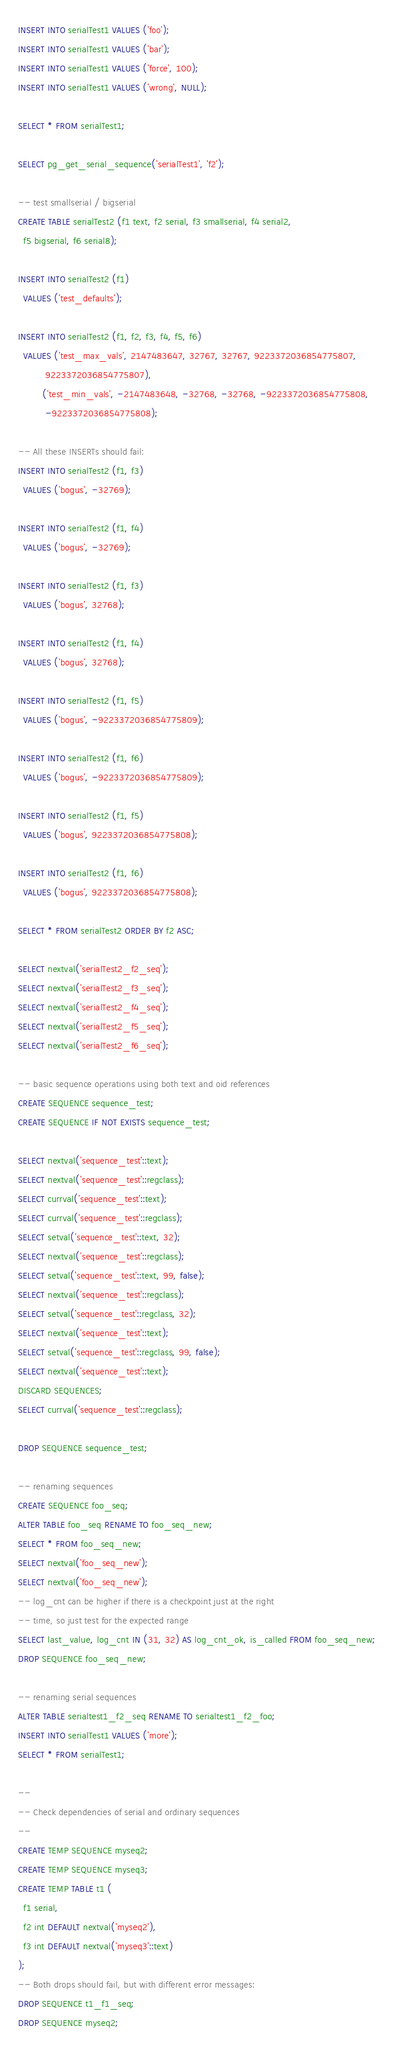<code> <loc_0><loc_0><loc_500><loc_500><_SQL_>INSERT INTO serialTest1 VALUES ('foo');
INSERT INTO serialTest1 VALUES ('bar');
INSERT INTO serialTest1 VALUES ('force', 100);
INSERT INTO serialTest1 VALUES ('wrong', NULL);

SELECT * FROM serialTest1;

SELECT pg_get_serial_sequence('serialTest1', 'f2');

-- test smallserial / bigserial
CREATE TABLE serialTest2 (f1 text, f2 serial, f3 smallserial, f4 serial2,
  f5 bigserial, f6 serial8);

INSERT INTO serialTest2 (f1)
  VALUES ('test_defaults');

INSERT INTO serialTest2 (f1, f2, f3, f4, f5, f6)
  VALUES ('test_max_vals', 2147483647, 32767, 32767, 9223372036854775807,
          9223372036854775807),
         ('test_min_vals', -2147483648, -32768, -32768, -9223372036854775808,
          -9223372036854775808);

-- All these INSERTs should fail:
INSERT INTO serialTest2 (f1, f3)
  VALUES ('bogus', -32769);

INSERT INTO serialTest2 (f1, f4)
  VALUES ('bogus', -32769);

INSERT INTO serialTest2 (f1, f3)
  VALUES ('bogus', 32768);

INSERT INTO serialTest2 (f1, f4)
  VALUES ('bogus', 32768);

INSERT INTO serialTest2 (f1, f5)
  VALUES ('bogus', -9223372036854775809);

INSERT INTO serialTest2 (f1, f6)
  VALUES ('bogus', -9223372036854775809);

INSERT INTO serialTest2 (f1, f5)
  VALUES ('bogus', 9223372036854775808);

INSERT INTO serialTest2 (f1, f6)
  VALUES ('bogus', 9223372036854775808);

SELECT * FROM serialTest2 ORDER BY f2 ASC;

SELECT nextval('serialTest2_f2_seq');
SELECT nextval('serialTest2_f3_seq');
SELECT nextval('serialTest2_f4_seq');
SELECT nextval('serialTest2_f5_seq');
SELECT nextval('serialTest2_f6_seq');

-- basic sequence operations using both text and oid references
CREATE SEQUENCE sequence_test;
CREATE SEQUENCE IF NOT EXISTS sequence_test;

SELECT nextval('sequence_test'::text);
SELECT nextval('sequence_test'::regclass);
SELECT currval('sequence_test'::text);
SELECT currval('sequence_test'::regclass);
SELECT setval('sequence_test'::text, 32);
SELECT nextval('sequence_test'::regclass);
SELECT setval('sequence_test'::text, 99, false);
SELECT nextval('sequence_test'::regclass);
SELECT setval('sequence_test'::regclass, 32);
SELECT nextval('sequence_test'::text);
SELECT setval('sequence_test'::regclass, 99, false);
SELECT nextval('sequence_test'::text);
DISCARD SEQUENCES;
SELECT currval('sequence_test'::regclass);

DROP SEQUENCE sequence_test;

-- renaming sequences
CREATE SEQUENCE foo_seq;
ALTER TABLE foo_seq RENAME TO foo_seq_new;
SELECT * FROM foo_seq_new;
SELECT nextval('foo_seq_new');
SELECT nextval('foo_seq_new');
-- log_cnt can be higher if there is a checkpoint just at the right
-- time, so just test for the expected range
SELECT last_value, log_cnt IN (31, 32) AS log_cnt_ok, is_called FROM foo_seq_new;
DROP SEQUENCE foo_seq_new;

-- renaming serial sequences
ALTER TABLE serialtest1_f2_seq RENAME TO serialtest1_f2_foo;
INSERT INTO serialTest1 VALUES ('more');
SELECT * FROM serialTest1;

--
-- Check dependencies of serial and ordinary sequences
--
CREATE TEMP SEQUENCE myseq2;
CREATE TEMP SEQUENCE myseq3;
CREATE TEMP TABLE t1 (
  f1 serial,
  f2 int DEFAULT nextval('myseq2'),
  f3 int DEFAULT nextval('myseq3'::text)
);
-- Both drops should fail, but with different error messages:
DROP SEQUENCE t1_f1_seq;
DROP SEQUENCE myseq2;</code> 